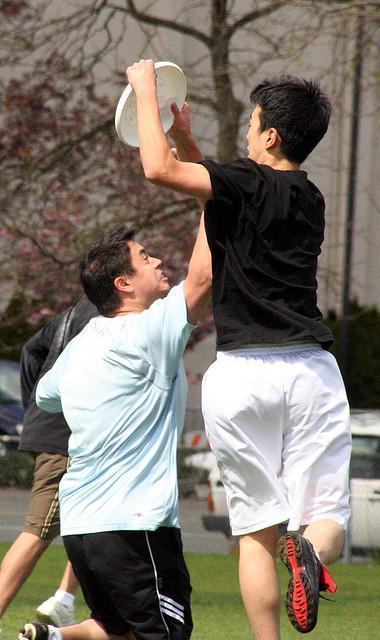How many people are there?
Give a very brief answer. 3. How many frisbees are in the picture?
Give a very brief answer. 1. How many people are visible?
Give a very brief answer. 3. 